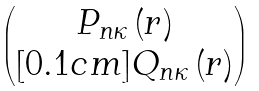Convert formula to latex. <formula><loc_0><loc_0><loc_500><loc_500>\begin{pmatrix} P _ { n \kappa } \, ( r ) \\ [ 0 . 1 c m ] Q _ { n \kappa } \, ( r ) \end{pmatrix}</formula> 